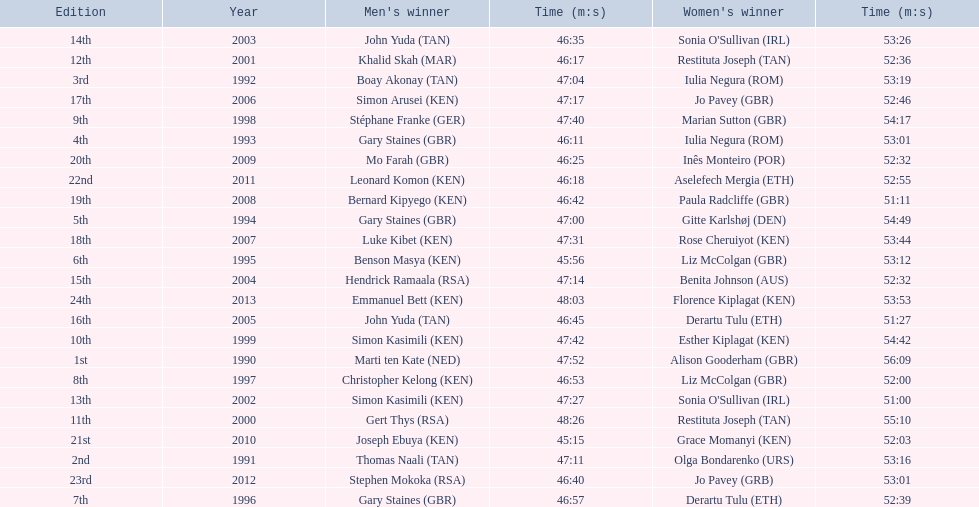Who were all the runners' times between 1990 and 2013? 47:52, 56:09, 47:11, 53:16, 47:04, 53:19, 46:11, 53:01, 47:00, 54:49, 45:56, 53:12, 46:57, 52:39, 46:53, 52:00, 47:40, 54:17, 47:42, 54:42, 48:26, 55:10, 46:17, 52:36, 47:27, 51:00, 46:35, 53:26, 47:14, 52:32, 46:45, 51:27, 47:17, 52:46, 47:31, 53:44, 46:42, 51:11, 46:25, 52:32, 45:15, 52:03, 46:18, 52:55, 46:40, 53:01, 48:03, 53:53. Which was the fastest time? 45:15. Who ran that time? Joseph Ebuya (KEN). 